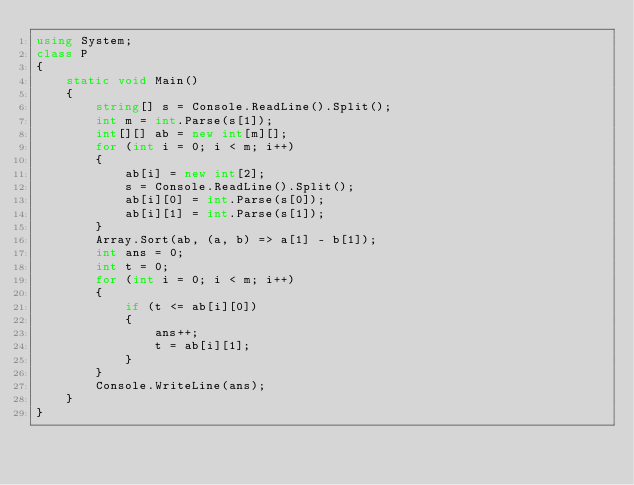<code> <loc_0><loc_0><loc_500><loc_500><_C#_>using System;
class P
{
    static void Main()
    {
        string[] s = Console.ReadLine().Split();
        int m = int.Parse(s[1]);
        int[][] ab = new int[m][];
        for (int i = 0; i < m; i++)
        {
            ab[i] = new int[2];
            s = Console.ReadLine().Split();
            ab[i][0] = int.Parse(s[0]);
            ab[i][1] = int.Parse(s[1]);
        }
        Array.Sort(ab, (a, b) => a[1] - b[1]);
        int ans = 0;
        int t = 0;
        for (int i = 0; i < m; i++)
        {
            if (t <= ab[i][0])
            {
                ans++;
                t = ab[i][1];
            }
        }
        Console.WriteLine(ans);
    }
}</code> 